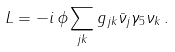Convert formula to latex. <formula><loc_0><loc_0><loc_500><loc_500>L = - i \, \phi \sum _ { j k } g _ { j k } \bar { \nu } _ { j } \gamma _ { 5 } \nu _ { k } \, .</formula> 